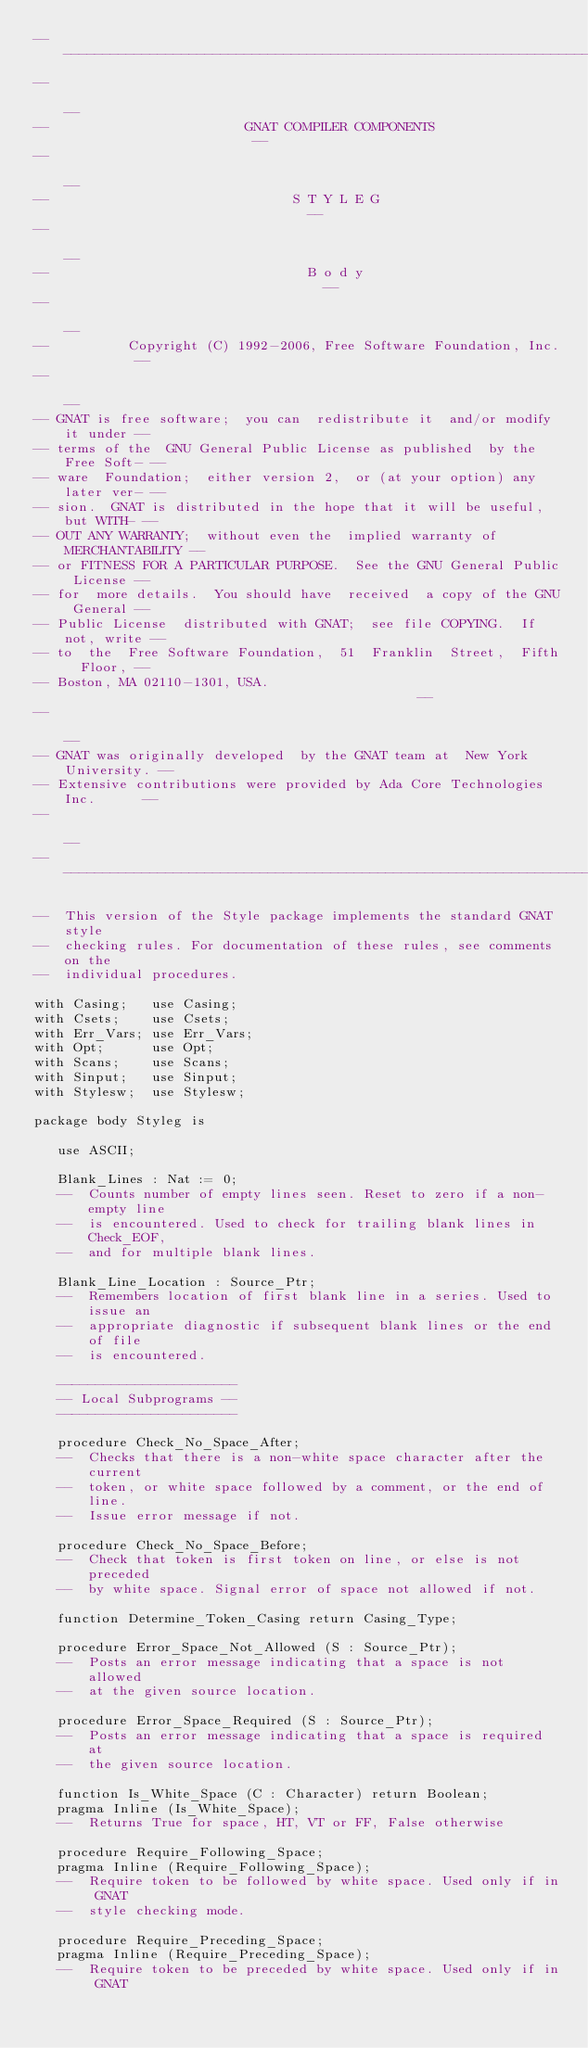Convert code to text. <code><loc_0><loc_0><loc_500><loc_500><_Ada_>------------------------------------------------------------------------------
--                                                                          --
--                         GNAT COMPILER COMPONENTS                         --
--                                                                          --
--                               S T Y L E G                                --
--                                                                          --
--                                 B o d y                                  --
--                                                                          --
--          Copyright (C) 1992-2006, Free Software Foundation, Inc.         --
--                                                                          --
-- GNAT is free software;  you can  redistribute it  and/or modify it under --
-- terms of the  GNU General Public License as published  by the Free Soft- --
-- ware  Foundation;  either version 2,  or (at your option) any later ver- --
-- sion.  GNAT is distributed in the hope that it will be useful, but WITH- --
-- OUT ANY WARRANTY;  without even the  implied warranty of MERCHANTABILITY --
-- or FITNESS FOR A PARTICULAR PURPOSE.  See the GNU General Public License --
-- for  more details.  You should have  received  a copy of the GNU General --
-- Public License  distributed with GNAT;  see file COPYING.  If not, write --
-- to  the  Free Software Foundation,  51  Franklin  Street,  Fifth  Floor, --
-- Boston, MA 02110-1301, USA.                                              --
--                                                                          --
-- GNAT was originally developed  by the GNAT team at  New York University. --
-- Extensive contributions were provided by Ada Core Technologies Inc.      --
--                                                                          --
------------------------------------------------------------------------------

--  This version of the Style package implements the standard GNAT style
--  checking rules. For documentation of these rules, see comments on the
--  individual procedures.

with Casing;   use Casing;
with Csets;    use Csets;
with Err_Vars; use Err_Vars;
with Opt;      use Opt;
with Scans;    use Scans;
with Sinput;   use Sinput;
with Stylesw;  use Stylesw;

package body Styleg is

   use ASCII;

   Blank_Lines : Nat := 0;
   --  Counts number of empty lines seen. Reset to zero if a non-empty line
   --  is encountered. Used to check for trailing blank lines in Check_EOF,
   --  and for multiple blank lines.

   Blank_Line_Location : Source_Ptr;
   --  Remembers location of first blank line in a series. Used to issue an
   --  appropriate diagnostic if subsequent blank lines or the end of file
   --  is encountered.

   -----------------------
   -- Local Subprograms --
   -----------------------

   procedure Check_No_Space_After;
   --  Checks that there is a non-white space character after the current
   --  token, or white space followed by a comment, or the end of line.
   --  Issue error message if not.

   procedure Check_No_Space_Before;
   --  Check that token is first token on line, or else is not preceded
   --  by white space. Signal error of space not allowed if not.

   function Determine_Token_Casing return Casing_Type;

   procedure Error_Space_Not_Allowed (S : Source_Ptr);
   --  Posts an error message indicating that a space is not allowed
   --  at the given source location.

   procedure Error_Space_Required (S : Source_Ptr);
   --  Posts an error message indicating that a space is required at
   --  the given source location.

   function Is_White_Space (C : Character) return Boolean;
   pragma Inline (Is_White_Space);
   --  Returns True for space, HT, VT or FF, False otherwise

   procedure Require_Following_Space;
   pragma Inline (Require_Following_Space);
   --  Require token to be followed by white space. Used only if in GNAT
   --  style checking mode.

   procedure Require_Preceding_Space;
   pragma Inline (Require_Preceding_Space);
   --  Require token to be preceded by white space. Used only if in GNAT</code> 